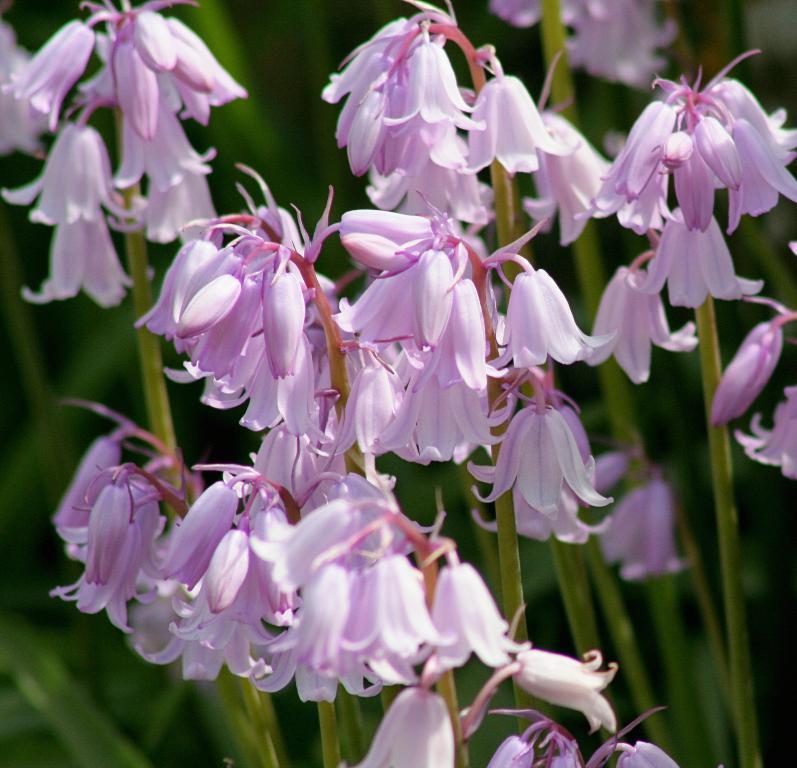How would you summarize this image in a sentence or two? In this picture there are pink color flowers in the image and there is greenery in the background area of the image. 